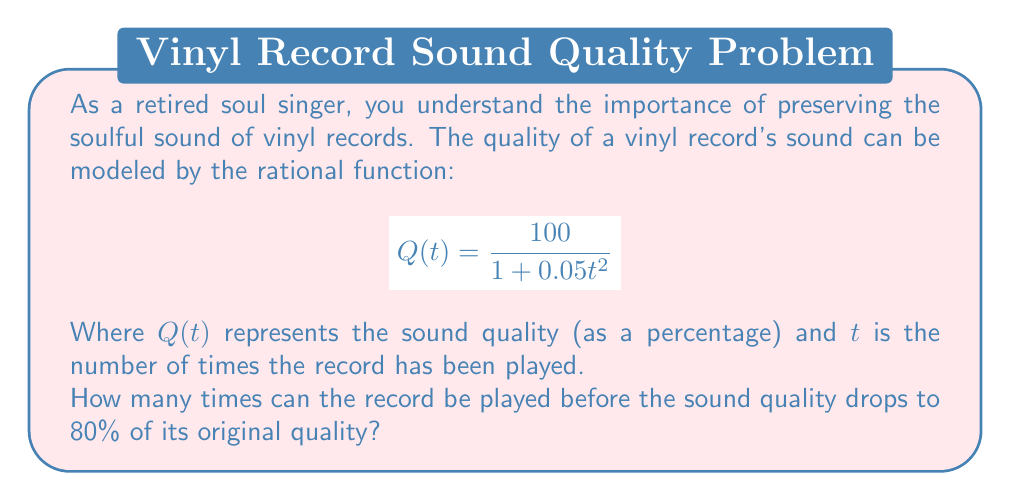Could you help me with this problem? Let's approach this step-by-step:

1) We want to find $t$ when $Q(t) = 80$. So, we set up the equation:

   $$80 = \frac{100}{1 + 0.05t^2}$$

2) Multiply both sides by $(1 + 0.05t^2)$:

   $$80(1 + 0.05t^2) = 100$$

3) Distribute on the left side:

   $$80 + 4t^2 = 100$$

4) Subtract 80 from both sides:

   $$4t^2 = 20$$

5) Divide both sides by 4:

   $$t^2 = 5$$

6) Take the square root of both sides:

   $$t = \sqrt{5}$$

7) Since $t$ represents the number of plays, we need to round down to the nearest whole number.

   $$t \approx 2.236$$

   Rounding down, we get 2.
Answer: 2 plays 